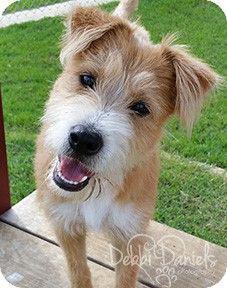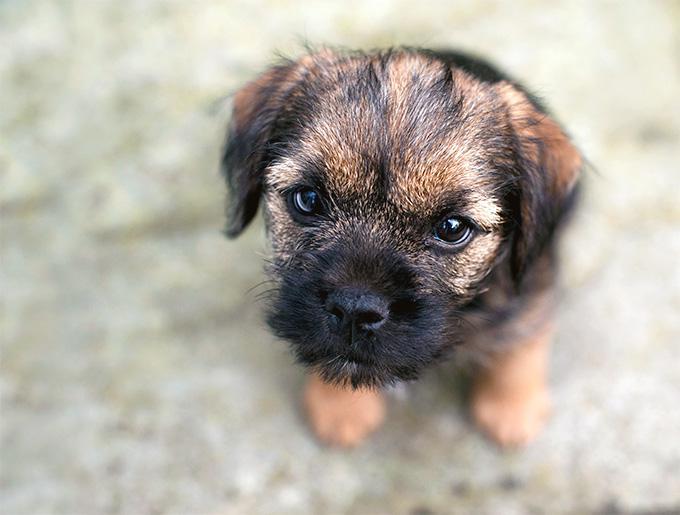The first image is the image on the left, the second image is the image on the right. Given the left and right images, does the statement "One dog has a collar or leash." hold true? Answer yes or no. No. The first image is the image on the left, the second image is the image on the right. For the images shown, is this caption "One photo shows the full body of an adult dog against a plain white background." true? Answer yes or no. No. 